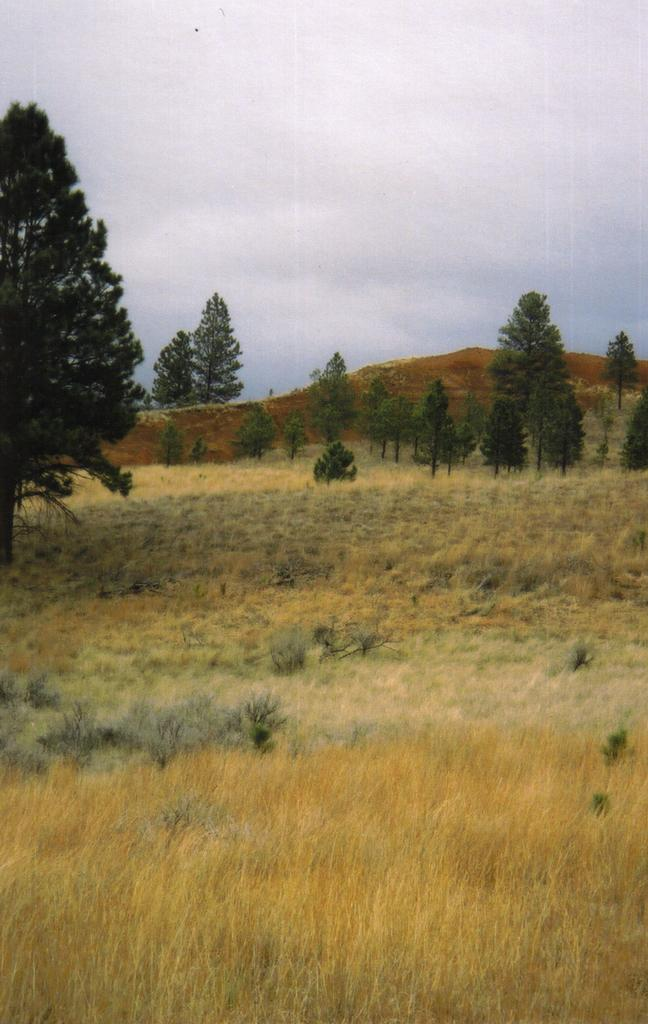What type of vegetation is present in the image? There is grass in the image. What can be seen in the background of the image? There are trees and a hill in the background of the image. What part of the natural environment is visible in the image? The sky is visible in the background of the image. What shape is the pencil in the image? There is no pencil present in the image. How does the grass make the area more quiet in the image? The grass does not make the area more quiet in the image; it is simply a visual element. 